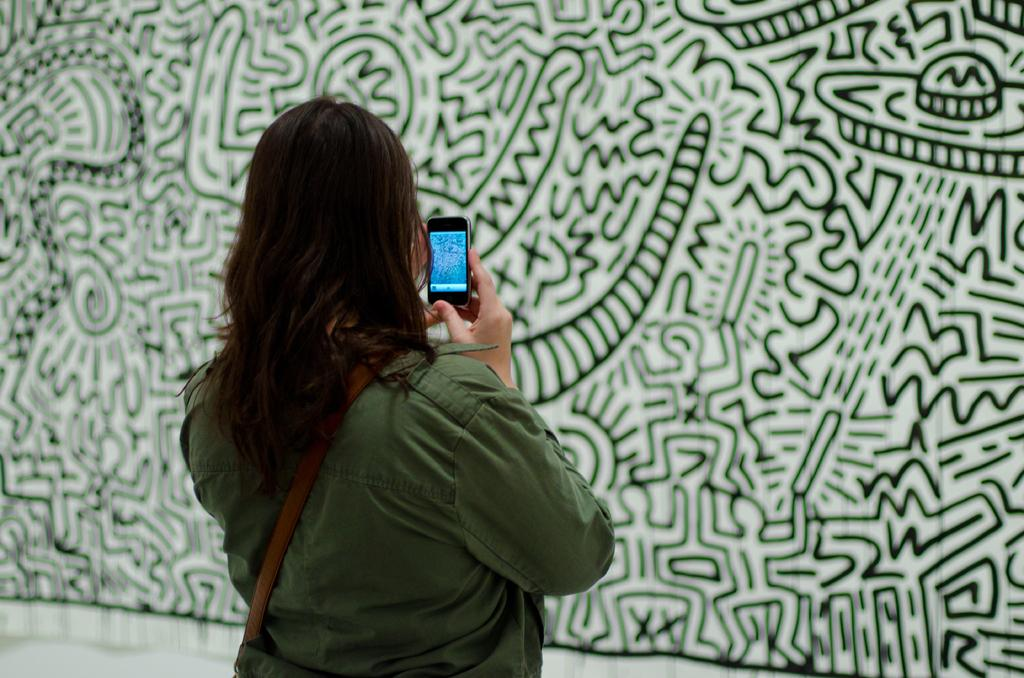Who is present in the image? There is a lady in the image. What is the lady holding in her hand? The lady is holding a phone. What is the lady doing with her phone? The lady is taking a picture with her phone. What can be seen in the background of the image? There is a graffiti wall in the image. How is the graffiti wall positioned in relation to the lady? The graffiti wall is opposite to the lady. What type of wren can be seen perched on the lady's finger in the image? There is no wren present in the image, nor is there any bird perched on the lady's finger. 